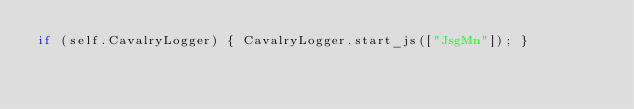<code> <loc_0><loc_0><loc_500><loc_500><_JavaScript_>if (self.CavalryLogger) { CavalryLogger.start_js(["JsgMn"]); }
</code> 